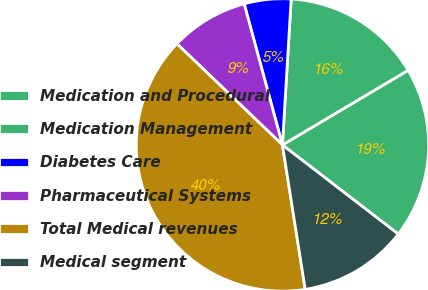Convert chart. <chart><loc_0><loc_0><loc_500><loc_500><pie_chart><fcel>Medication and Procedural<fcel>Medication Management<fcel>Diabetes Care<fcel>Pharmaceutical Systems<fcel>Total Medical revenues<fcel>Medical segment<nl><fcel>18.97%<fcel>15.52%<fcel>5.17%<fcel>8.62%<fcel>39.66%<fcel>12.07%<nl></chart> 